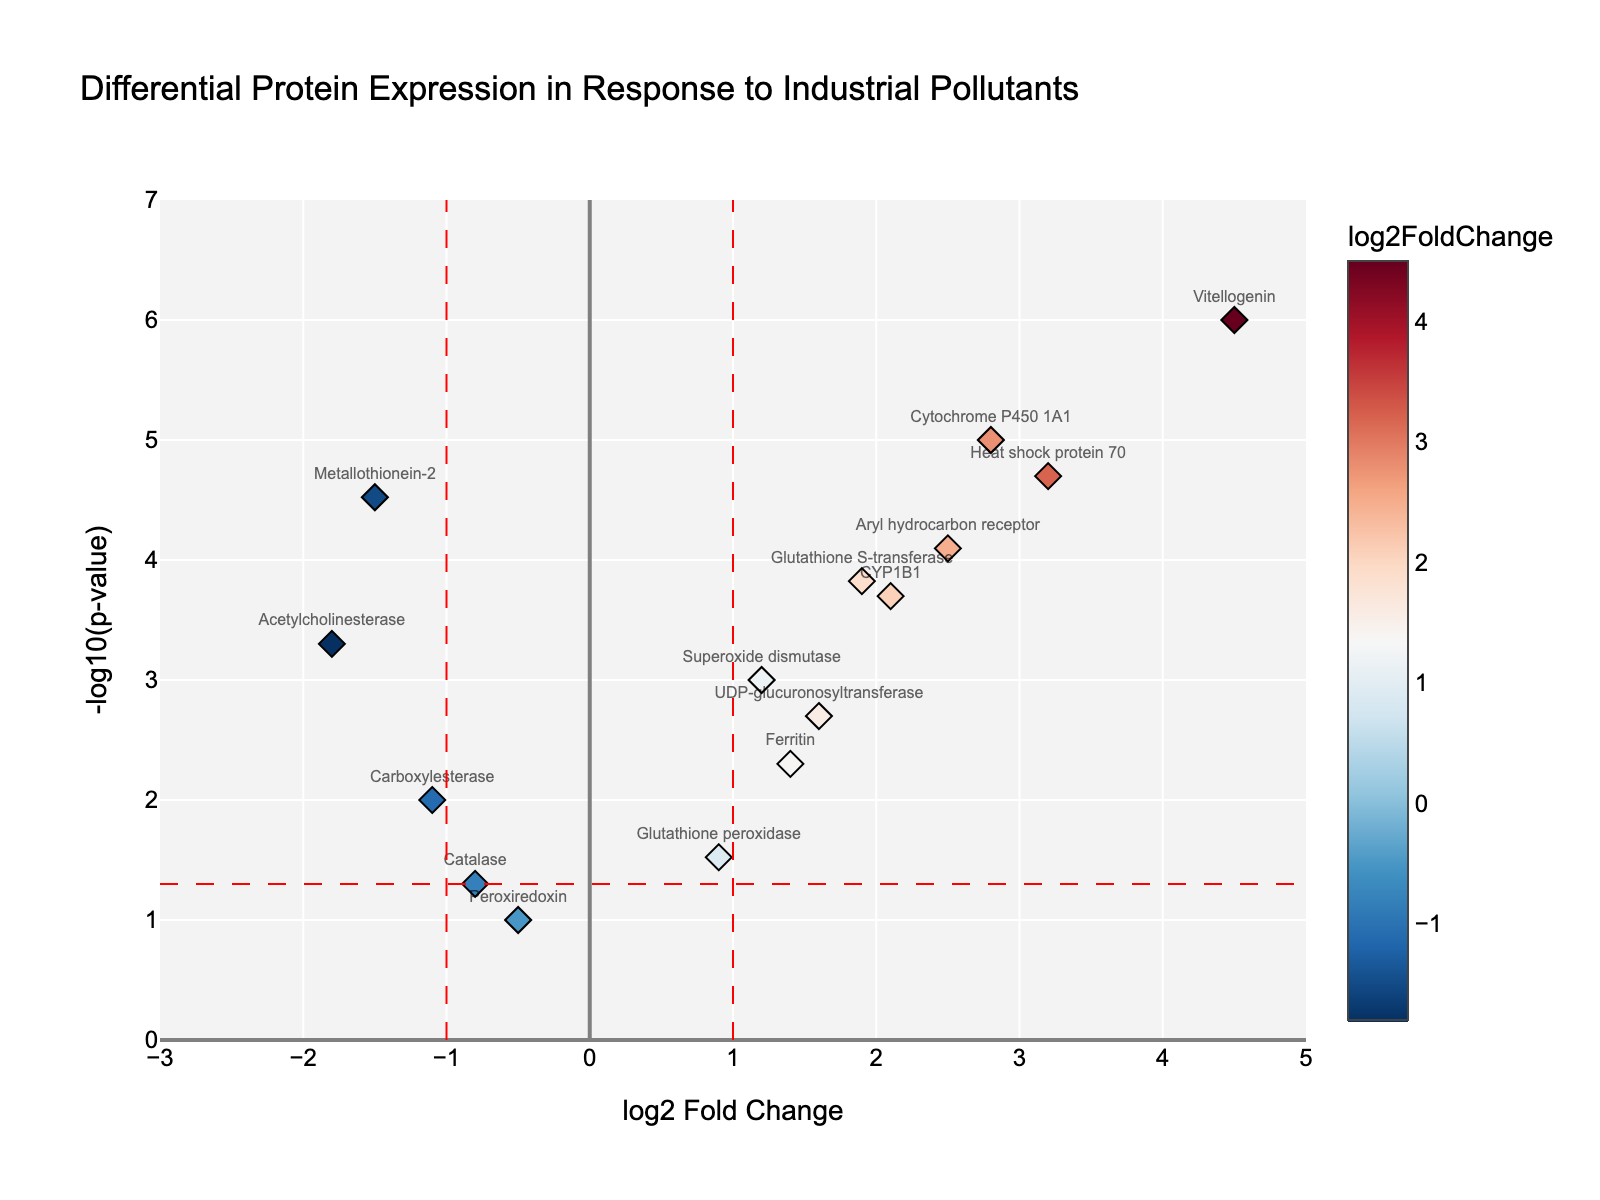What's the title of the plot? The title of the plot is prominently displayed at the top of the figure. It clearly labels the visualization.
Answer: Differential Protein Expression in Response to Industrial Pollutants What are the names of the x-axis and y-axis? The axes labels can be found next to each axis. They indicate what the values on each axis represent.
Answer: x-axis: log2 Fold Change, y-axis: -log10(p-value) How many data points are below the significance threshold? The significance threshold is represented by the horizontal red dashed line at y = -log10(0.05). Count the points below this line.
Answer: 2 Which protein has the highest -log10(p-value)? Identify the protein with the highest position on the y-axis, as -log10(p-value) increases upwards.
Answer: Vitellogenin Are there any proteins with log2 Fold Change less than -1? Check the left side of the x-axis, to the left of the vertical red dashed line at x = -1, for any data points.
Answer: Yes Which proteins are both significantly upregulated and downregulated? Proteins with log2 Fold Change greater than 1 or less than -1 and -log10(p-value) above the significance threshold (y > -log10(0.05)) are significant. Identify the ones meeting these criteria.
Answer: Upregulated: Cytochrome P450 1A1, Heat shock protein 70, Glutathione S-transferase, Vitellogenin, CYP1B1, Aryl hydrocarbon receptor. Downregulated: Metallothionein-2, Acetylcholinesterase What color represents the highest log2 Fold Change? The color of the points on the scatter plot represents the log2 Fold Change, with a color bar indicating the scale. Identify the color corresponding to the highest value on this scale.
Answer: Red Which protein shows the lowest fold change but is still significantly expressed? Determine the data point with the lowest value on the x-axis (log2FoldChange) that's above the significance threshold (y > -log10(0.05)).
Answer: Metallothionein-2 How many proteins are not significantly expressed? Count the data points below the significance threshold line (y = -log10(0.05)).
Answer: 2 Which protein has the closest fold change to zero but is significantly expressed? Locate the data point near the vertical line at x = 0 but above the horizontal significance threshold (y > -log10(0.05)).
Answer: Ferritin 